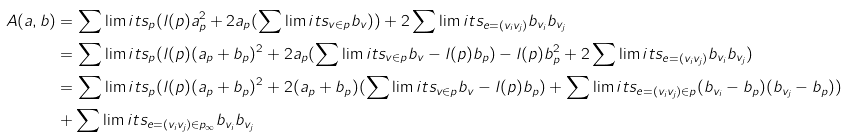<formula> <loc_0><loc_0><loc_500><loc_500>A ( a , b ) & = \sum \lim i t s _ { p } ( l ( p ) a _ { p } ^ { 2 } + 2 a _ { p } ( \sum \lim i t s _ { v \in p } b _ { v } ) ) + 2 \sum \lim i t s _ { e = ( v _ { i } v _ { j } ) } b _ { v _ { i } } b _ { v _ { j } } \\ & = \sum \lim i t s _ { p } ( l ( p ) ( a _ { p } + b _ { p } ) ^ { 2 } + 2 a _ { p } ( \sum \lim i t s _ { v \in p } b _ { v } - l ( p ) b _ { p } ) - l ( p ) b _ { p } ^ { 2 } + 2 \sum \lim i t s _ { e = ( v _ { i } v _ { j } ) } b _ { v _ { i } } b _ { v _ { j } } ) \\ & = \sum \lim i t s _ { p } ( l ( p ) ( a _ { p } + b _ { p } ) ^ { 2 } + 2 ( a _ { p } + b _ { p } ) ( \sum \lim i t s _ { v \in p } b _ { v } - l ( p ) b _ { p } ) + \sum \lim i t s _ { e = ( v _ { i } v _ { j } ) \in p } ( b _ { v _ { i } } - b _ { p } ) ( b _ { v _ { j } } - b _ { p } ) ) \\ & + \sum \lim i t s _ { e = ( v _ { i } v _ { j } ) \in p _ { \infty } } b _ { v _ { i } } b _ { v _ { j } }</formula> 